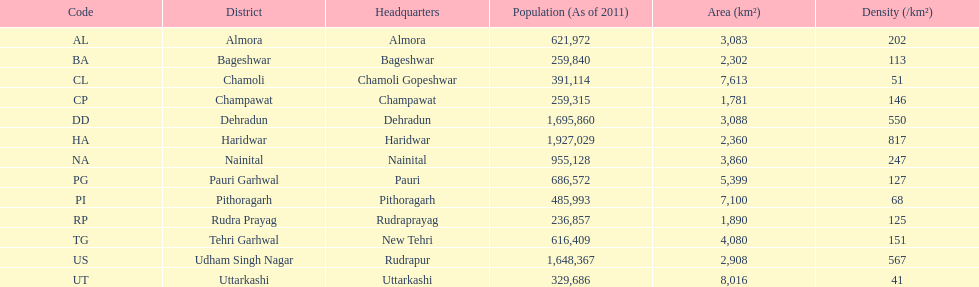What is the overall number of districts mentioned? 13. 